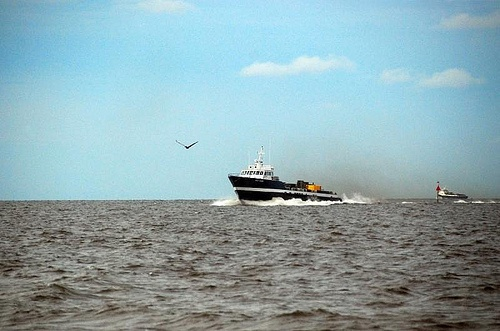Describe the objects in this image and their specific colors. I can see boat in gray, black, ivory, and darkgray tones, boat in gray, black, darkgray, and ivory tones, and bird in gray, lightblue, black, and darkgray tones in this image. 